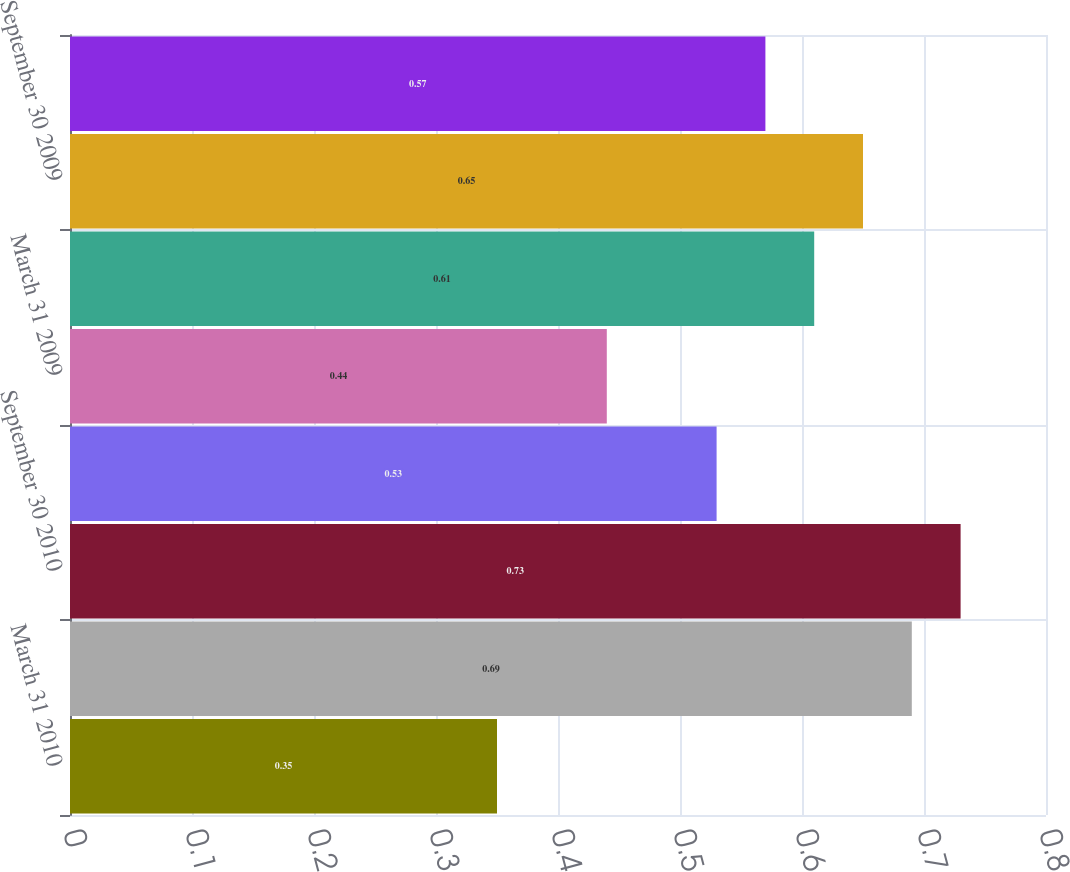<chart> <loc_0><loc_0><loc_500><loc_500><bar_chart><fcel>March 31 2010<fcel>June 30 2010<fcel>September 30 2010<fcel>December 31 2010<fcel>March 31 2009<fcel>June 30 2009<fcel>September 30 2009<fcel>December 31 2009<nl><fcel>0.35<fcel>0.69<fcel>0.73<fcel>0.53<fcel>0.44<fcel>0.61<fcel>0.65<fcel>0.57<nl></chart> 